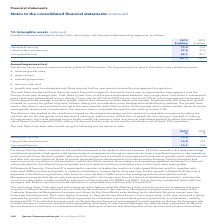According to Spirent Communications Plc's financial document, What has Goodwill been allocated to? three CGUs, which align with the reportable operating segments. The document states: "e assets continued Goodwill has been allocated to three CGUs, which align with the reportable operating segments, as follows:..." Also, What is the amount of intangible assets under Networks & Security in 2019? According to the financial document, 73.4 (in millions). The relevant text states: "Networks & Security 73.4 72.0..." Also, What are the three CGUs, which align with the reportable operating segments? The document contains multiple relevant values: Networks & Security, Lifecycle Service Assurance, Connected Devices. From the document: "Networks & Security 73.4 72.0 Lifecycle Service Assurance 37.6 37.6 Connected Devices 46.1 46.1..." Additionally, In which year was the amount of intangible assets larger? According to the financial document, 2019. The relevant text states: "2019 2018..." Also, can you calculate: What was the change in the total intangible assets? Based on the calculation: 157.1-155.7, the result is 1.4 (in millions). This is based on the information: "157.1 155.7 157.1 155.7..." The key data points involved are: 155.7, 157.1. Also, can you calculate: What was the percentage change in the total intangible assets? To answer this question, I need to perform calculations using the financial data. The calculation is: (157.1-155.7)/155.7, which equals 0.9 (percentage). This is based on the information: "157.1 155.7 157.1 155.7..." The key data points involved are: 155.7, 157.1. 